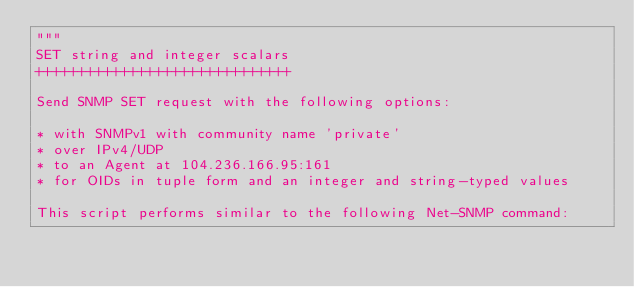<code> <loc_0><loc_0><loc_500><loc_500><_Python_>"""
SET string and integer scalars
++++++++++++++++++++++++++++++

Send SNMP SET request with the following options:

* with SNMPv1 with community name 'private'
* over IPv4/UDP
* to an Agent at 104.236.166.95:161
* for OIDs in tuple form and an integer and string-typed values

This script performs similar to the following Net-SNMP command:
</code> 